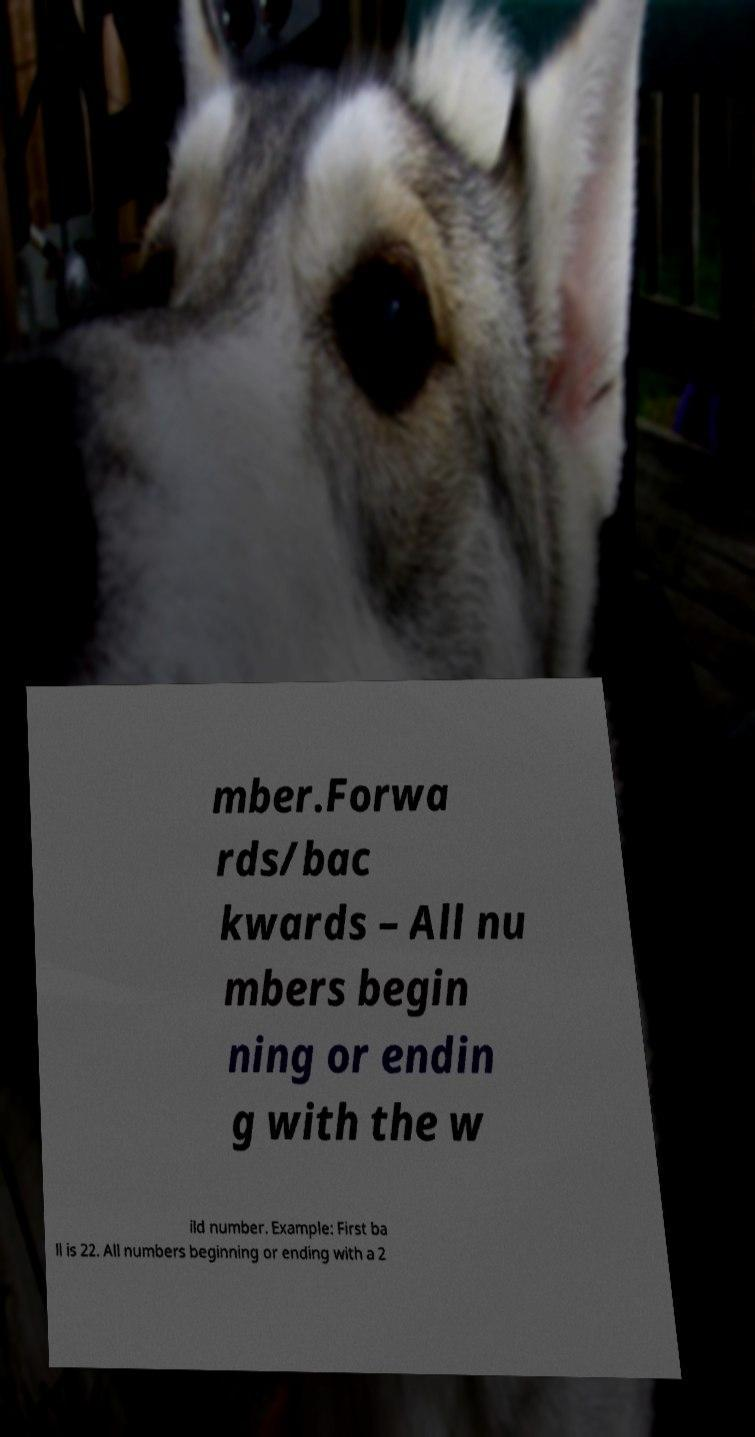What messages or text are displayed in this image? I need them in a readable, typed format. mber.Forwa rds/bac kwards – All nu mbers begin ning or endin g with the w ild number. Example: First ba ll is 22. All numbers beginning or ending with a 2 